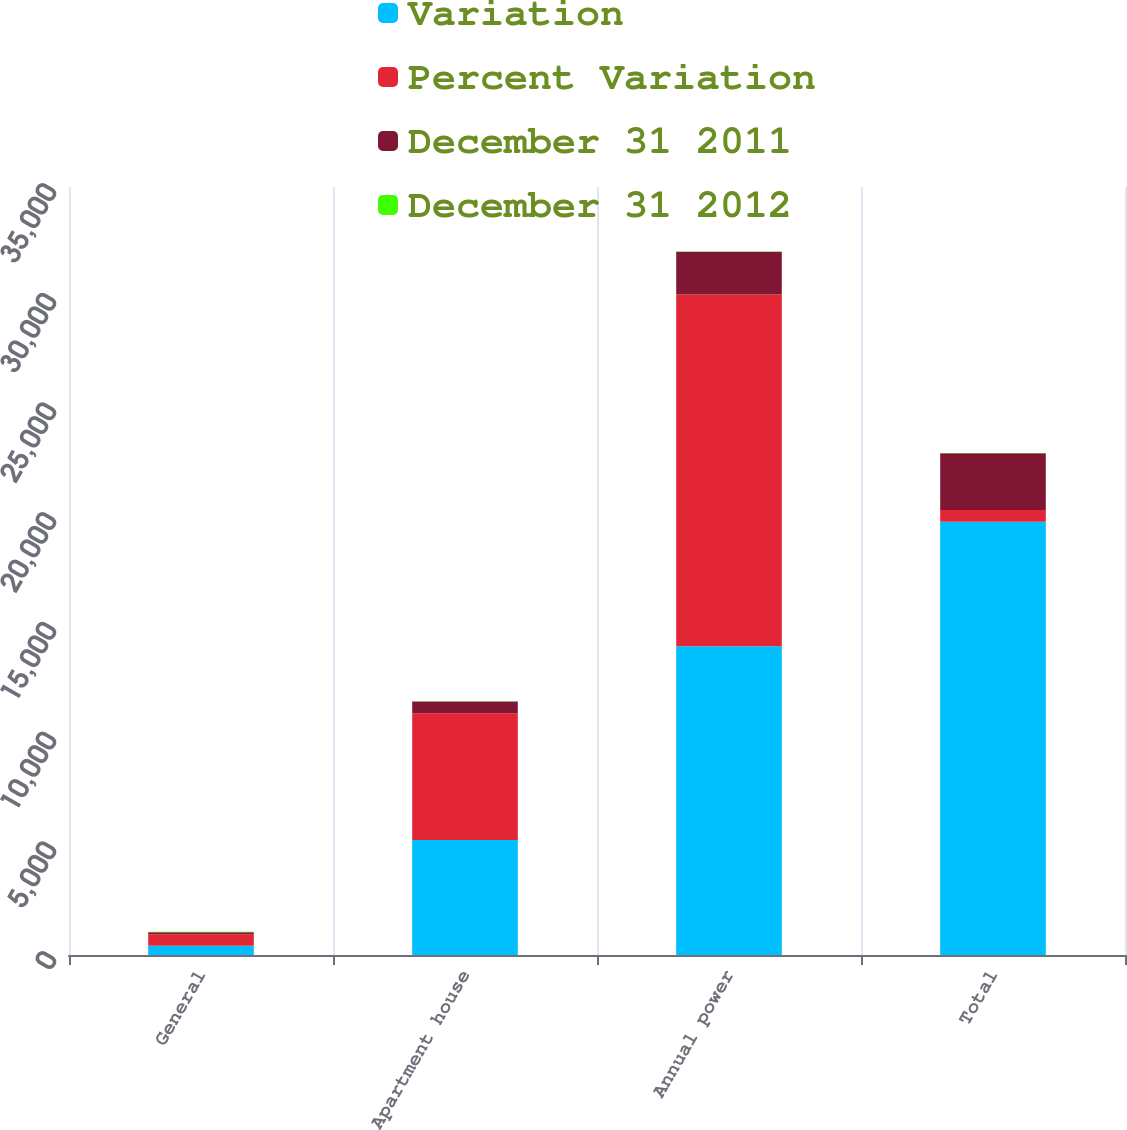<chart> <loc_0><loc_0><loc_500><loc_500><stacked_bar_chart><ecel><fcel>General<fcel>Apartment house<fcel>Annual power<fcel>Total<nl><fcel>Variation<fcel>425<fcel>5240<fcel>14076<fcel>19741<nl><fcel>Percent Variation<fcel>519<fcel>5779<fcel>16024<fcel>539<nl><fcel>December 31 2011<fcel>94<fcel>539<fcel>1948<fcel>2581<nl><fcel>December 31 2012<fcel>18.1<fcel>9.3<fcel>12.2<fcel>11.6<nl></chart> 